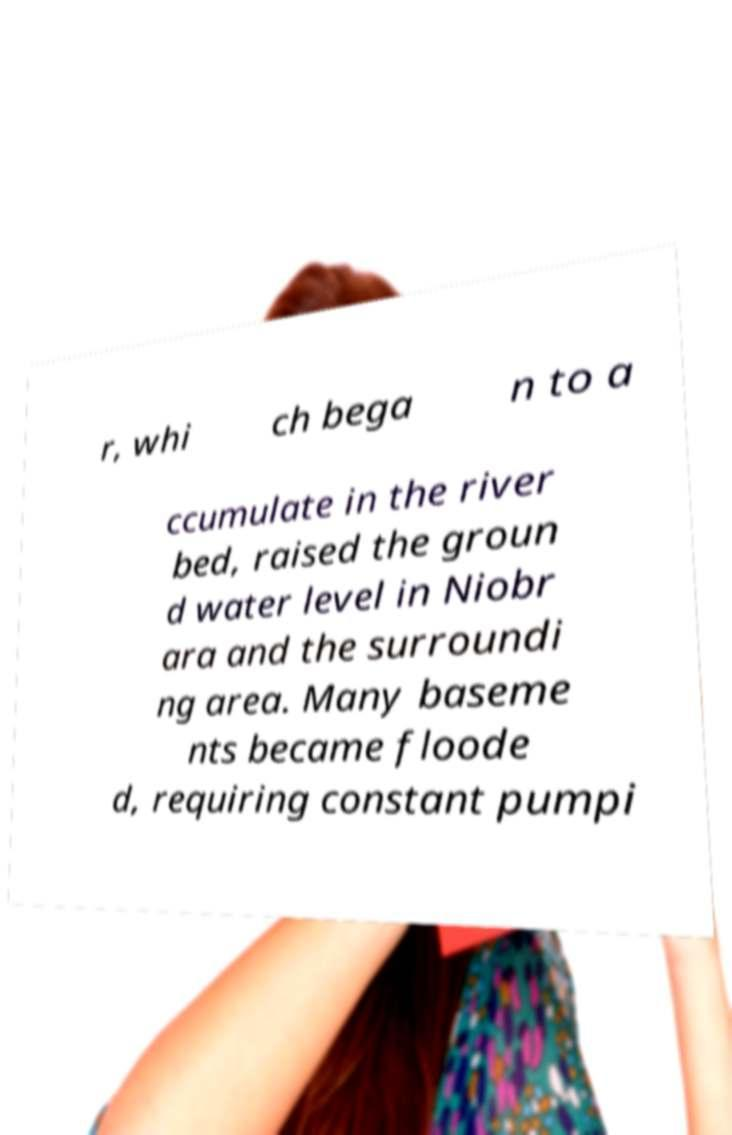Please identify and transcribe the text found in this image. r, whi ch bega n to a ccumulate in the river bed, raised the groun d water level in Niobr ara and the surroundi ng area. Many baseme nts became floode d, requiring constant pumpi 